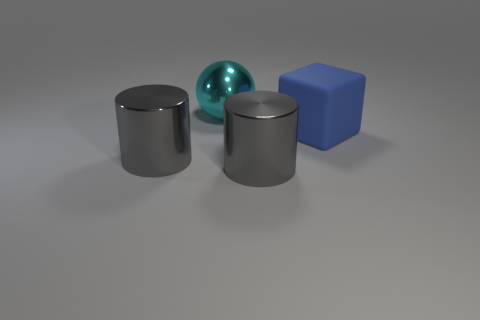Is there anything else that is the same shape as the blue matte object?
Provide a succinct answer. No. There is a big metal thing that is in front of the big metal object that is to the left of the cyan object; what is its shape?
Make the answer very short. Cylinder. Does the big matte cube have the same color as the large ball?
Keep it short and to the point. No. What number of gray objects are large metal cylinders or metal balls?
Your answer should be compact. 2. Are there any gray objects right of the cube?
Offer a terse response. No. How big is the blue rubber cube?
Provide a short and direct response. Large. There is a big cylinder on the right side of the ball; how many cyan things are behind it?
Give a very brief answer. 1. Is the gray thing that is left of the cyan metallic object made of the same material as the object that is behind the big blue cube?
Make the answer very short. Yes. How many other big cyan metallic things are the same shape as the large cyan thing?
Your answer should be compact. 0. How many other big metallic balls have the same color as the large metallic sphere?
Your response must be concise. 0. 